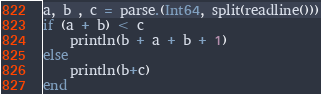<code> <loc_0><loc_0><loc_500><loc_500><_Julia_>a, b , c = parse.(Int64, split(readline()))
if (a + b) < c
    println(b + a + b + 1)
else
    println(b+c)
end</code> 